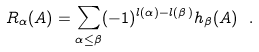Convert formula to latex. <formula><loc_0><loc_0><loc_500><loc_500>R _ { \alpha } ( A ) = \sum _ { \alpha \leq \beta } ( - 1 ) ^ { l ( \alpha ) - l ( \beta ) } h _ { \beta } ( A ) \ .</formula> 